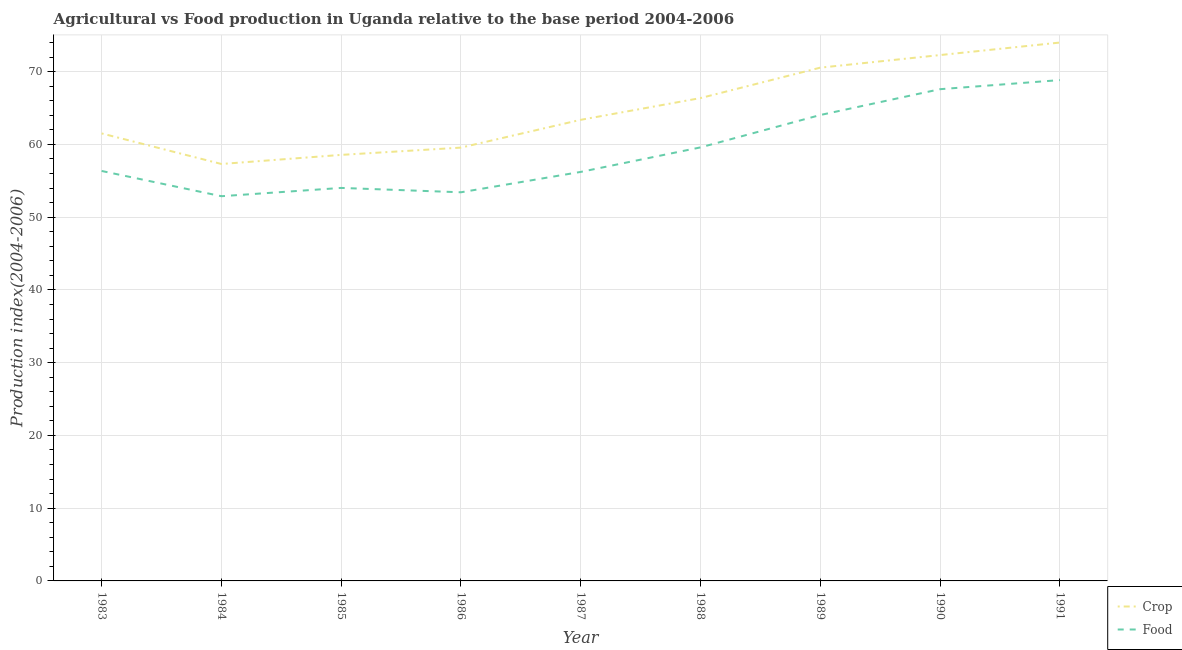What is the crop production index in 1990?
Provide a short and direct response. 72.28. Across all years, what is the minimum crop production index?
Provide a succinct answer. 57.31. In which year was the crop production index minimum?
Your response must be concise. 1984. What is the total crop production index in the graph?
Your answer should be very brief. 583.52. What is the difference between the crop production index in 1983 and that in 1990?
Your answer should be compact. -10.77. What is the difference between the food production index in 1989 and the crop production index in 1990?
Offer a very short reply. -8.24. What is the average food production index per year?
Provide a succinct answer. 59.22. In the year 1989, what is the difference between the food production index and crop production index?
Keep it short and to the point. -6.51. What is the ratio of the crop production index in 1983 to that in 1991?
Your answer should be very brief. 0.83. Is the food production index in 1984 less than that in 1985?
Your response must be concise. Yes. What is the difference between the highest and the second highest crop production index?
Offer a terse response. 1.72. What is the difference between the highest and the lowest food production index?
Ensure brevity in your answer.  15.96. Does the crop production index monotonically increase over the years?
Give a very brief answer. No. Is the crop production index strictly greater than the food production index over the years?
Offer a terse response. Yes. Is the food production index strictly less than the crop production index over the years?
Ensure brevity in your answer.  Yes. How many years are there in the graph?
Your response must be concise. 9. Does the graph contain any zero values?
Offer a terse response. No. How many legend labels are there?
Provide a succinct answer. 2. What is the title of the graph?
Keep it short and to the point. Agricultural vs Food production in Uganda relative to the base period 2004-2006. What is the label or title of the X-axis?
Offer a terse response. Year. What is the label or title of the Y-axis?
Offer a very short reply. Production index(2004-2006). What is the Production index(2004-2006) in Crop in 1983?
Provide a short and direct response. 61.51. What is the Production index(2004-2006) in Food in 1983?
Keep it short and to the point. 56.35. What is the Production index(2004-2006) of Crop in 1984?
Make the answer very short. 57.31. What is the Production index(2004-2006) of Food in 1984?
Keep it short and to the point. 52.88. What is the Production index(2004-2006) in Crop in 1985?
Your answer should be very brief. 58.56. What is the Production index(2004-2006) of Food in 1985?
Provide a succinct answer. 54.02. What is the Production index(2004-2006) of Crop in 1986?
Keep it short and to the point. 59.56. What is the Production index(2004-2006) of Food in 1986?
Provide a succinct answer. 53.42. What is the Production index(2004-2006) of Crop in 1987?
Offer a terse response. 63.38. What is the Production index(2004-2006) of Food in 1987?
Keep it short and to the point. 56.22. What is the Production index(2004-2006) of Crop in 1988?
Give a very brief answer. 66.37. What is the Production index(2004-2006) in Food in 1988?
Your response must be concise. 59.59. What is the Production index(2004-2006) in Crop in 1989?
Give a very brief answer. 70.55. What is the Production index(2004-2006) of Food in 1989?
Keep it short and to the point. 64.04. What is the Production index(2004-2006) of Crop in 1990?
Offer a very short reply. 72.28. What is the Production index(2004-2006) of Food in 1990?
Provide a short and direct response. 67.59. What is the Production index(2004-2006) in Food in 1991?
Your answer should be very brief. 68.84. Across all years, what is the maximum Production index(2004-2006) of Food?
Provide a short and direct response. 68.84. Across all years, what is the minimum Production index(2004-2006) of Crop?
Your answer should be very brief. 57.31. Across all years, what is the minimum Production index(2004-2006) in Food?
Give a very brief answer. 52.88. What is the total Production index(2004-2006) in Crop in the graph?
Offer a very short reply. 583.52. What is the total Production index(2004-2006) in Food in the graph?
Your response must be concise. 532.95. What is the difference between the Production index(2004-2006) of Crop in 1983 and that in 1984?
Offer a terse response. 4.2. What is the difference between the Production index(2004-2006) in Food in 1983 and that in 1984?
Ensure brevity in your answer.  3.47. What is the difference between the Production index(2004-2006) in Crop in 1983 and that in 1985?
Provide a short and direct response. 2.95. What is the difference between the Production index(2004-2006) of Food in 1983 and that in 1985?
Your response must be concise. 2.33. What is the difference between the Production index(2004-2006) of Crop in 1983 and that in 1986?
Keep it short and to the point. 1.95. What is the difference between the Production index(2004-2006) in Food in 1983 and that in 1986?
Offer a terse response. 2.93. What is the difference between the Production index(2004-2006) in Crop in 1983 and that in 1987?
Keep it short and to the point. -1.87. What is the difference between the Production index(2004-2006) in Food in 1983 and that in 1987?
Provide a succinct answer. 0.13. What is the difference between the Production index(2004-2006) of Crop in 1983 and that in 1988?
Offer a terse response. -4.86. What is the difference between the Production index(2004-2006) of Food in 1983 and that in 1988?
Your answer should be very brief. -3.24. What is the difference between the Production index(2004-2006) of Crop in 1983 and that in 1989?
Provide a succinct answer. -9.04. What is the difference between the Production index(2004-2006) of Food in 1983 and that in 1989?
Make the answer very short. -7.69. What is the difference between the Production index(2004-2006) in Crop in 1983 and that in 1990?
Offer a very short reply. -10.77. What is the difference between the Production index(2004-2006) in Food in 1983 and that in 1990?
Your answer should be compact. -11.24. What is the difference between the Production index(2004-2006) of Crop in 1983 and that in 1991?
Give a very brief answer. -12.49. What is the difference between the Production index(2004-2006) of Food in 1983 and that in 1991?
Your answer should be very brief. -12.49. What is the difference between the Production index(2004-2006) of Crop in 1984 and that in 1985?
Offer a very short reply. -1.25. What is the difference between the Production index(2004-2006) in Food in 1984 and that in 1985?
Your response must be concise. -1.14. What is the difference between the Production index(2004-2006) in Crop in 1984 and that in 1986?
Ensure brevity in your answer.  -2.25. What is the difference between the Production index(2004-2006) in Food in 1984 and that in 1986?
Offer a very short reply. -0.54. What is the difference between the Production index(2004-2006) of Crop in 1984 and that in 1987?
Make the answer very short. -6.07. What is the difference between the Production index(2004-2006) of Food in 1984 and that in 1987?
Ensure brevity in your answer.  -3.34. What is the difference between the Production index(2004-2006) of Crop in 1984 and that in 1988?
Give a very brief answer. -9.06. What is the difference between the Production index(2004-2006) of Food in 1984 and that in 1988?
Make the answer very short. -6.71. What is the difference between the Production index(2004-2006) of Crop in 1984 and that in 1989?
Keep it short and to the point. -13.24. What is the difference between the Production index(2004-2006) of Food in 1984 and that in 1989?
Offer a terse response. -11.16. What is the difference between the Production index(2004-2006) in Crop in 1984 and that in 1990?
Provide a succinct answer. -14.97. What is the difference between the Production index(2004-2006) of Food in 1984 and that in 1990?
Provide a succinct answer. -14.71. What is the difference between the Production index(2004-2006) in Crop in 1984 and that in 1991?
Your answer should be compact. -16.69. What is the difference between the Production index(2004-2006) in Food in 1984 and that in 1991?
Make the answer very short. -15.96. What is the difference between the Production index(2004-2006) in Crop in 1985 and that in 1986?
Provide a short and direct response. -1. What is the difference between the Production index(2004-2006) in Food in 1985 and that in 1986?
Your answer should be compact. 0.6. What is the difference between the Production index(2004-2006) in Crop in 1985 and that in 1987?
Offer a very short reply. -4.82. What is the difference between the Production index(2004-2006) in Food in 1985 and that in 1987?
Offer a terse response. -2.2. What is the difference between the Production index(2004-2006) of Crop in 1985 and that in 1988?
Make the answer very short. -7.81. What is the difference between the Production index(2004-2006) of Food in 1985 and that in 1988?
Provide a succinct answer. -5.57. What is the difference between the Production index(2004-2006) of Crop in 1985 and that in 1989?
Offer a very short reply. -11.99. What is the difference between the Production index(2004-2006) of Food in 1985 and that in 1989?
Keep it short and to the point. -10.02. What is the difference between the Production index(2004-2006) in Crop in 1985 and that in 1990?
Provide a short and direct response. -13.72. What is the difference between the Production index(2004-2006) in Food in 1985 and that in 1990?
Make the answer very short. -13.57. What is the difference between the Production index(2004-2006) of Crop in 1985 and that in 1991?
Your answer should be compact. -15.44. What is the difference between the Production index(2004-2006) in Food in 1985 and that in 1991?
Your answer should be very brief. -14.82. What is the difference between the Production index(2004-2006) in Crop in 1986 and that in 1987?
Your answer should be compact. -3.82. What is the difference between the Production index(2004-2006) in Food in 1986 and that in 1987?
Offer a terse response. -2.8. What is the difference between the Production index(2004-2006) of Crop in 1986 and that in 1988?
Offer a terse response. -6.81. What is the difference between the Production index(2004-2006) in Food in 1986 and that in 1988?
Your answer should be compact. -6.17. What is the difference between the Production index(2004-2006) in Crop in 1986 and that in 1989?
Make the answer very short. -10.99. What is the difference between the Production index(2004-2006) of Food in 1986 and that in 1989?
Your answer should be very brief. -10.62. What is the difference between the Production index(2004-2006) in Crop in 1986 and that in 1990?
Make the answer very short. -12.72. What is the difference between the Production index(2004-2006) of Food in 1986 and that in 1990?
Make the answer very short. -14.17. What is the difference between the Production index(2004-2006) of Crop in 1986 and that in 1991?
Your answer should be compact. -14.44. What is the difference between the Production index(2004-2006) in Food in 1986 and that in 1991?
Make the answer very short. -15.42. What is the difference between the Production index(2004-2006) of Crop in 1987 and that in 1988?
Your answer should be very brief. -2.99. What is the difference between the Production index(2004-2006) in Food in 1987 and that in 1988?
Ensure brevity in your answer.  -3.37. What is the difference between the Production index(2004-2006) in Crop in 1987 and that in 1989?
Your answer should be compact. -7.17. What is the difference between the Production index(2004-2006) of Food in 1987 and that in 1989?
Provide a short and direct response. -7.82. What is the difference between the Production index(2004-2006) of Food in 1987 and that in 1990?
Make the answer very short. -11.37. What is the difference between the Production index(2004-2006) in Crop in 1987 and that in 1991?
Keep it short and to the point. -10.62. What is the difference between the Production index(2004-2006) in Food in 1987 and that in 1991?
Offer a terse response. -12.62. What is the difference between the Production index(2004-2006) in Crop in 1988 and that in 1989?
Offer a terse response. -4.18. What is the difference between the Production index(2004-2006) of Food in 1988 and that in 1989?
Offer a terse response. -4.45. What is the difference between the Production index(2004-2006) of Crop in 1988 and that in 1990?
Your answer should be very brief. -5.91. What is the difference between the Production index(2004-2006) of Crop in 1988 and that in 1991?
Your answer should be compact. -7.63. What is the difference between the Production index(2004-2006) in Food in 1988 and that in 1991?
Provide a short and direct response. -9.25. What is the difference between the Production index(2004-2006) of Crop in 1989 and that in 1990?
Offer a very short reply. -1.73. What is the difference between the Production index(2004-2006) in Food in 1989 and that in 1990?
Offer a terse response. -3.55. What is the difference between the Production index(2004-2006) in Crop in 1989 and that in 1991?
Provide a short and direct response. -3.45. What is the difference between the Production index(2004-2006) in Crop in 1990 and that in 1991?
Offer a terse response. -1.72. What is the difference between the Production index(2004-2006) in Food in 1990 and that in 1991?
Provide a short and direct response. -1.25. What is the difference between the Production index(2004-2006) in Crop in 1983 and the Production index(2004-2006) in Food in 1984?
Offer a terse response. 8.63. What is the difference between the Production index(2004-2006) of Crop in 1983 and the Production index(2004-2006) of Food in 1985?
Your answer should be compact. 7.49. What is the difference between the Production index(2004-2006) of Crop in 1983 and the Production index(2004-2006) of Food in 1986?
Provide a short and direct response. 8.09. What is the difference between the Production index(2004-2006) in Crop in 1983 and the Production index(2004-2006) in Food in 1987?
Your answer should be very brief. 5.29. What is the difference between the Production index(2004-2006) in Crop in 1983 and the Production index(2004-2006) in Food in 1988?
Provide a short and direct response. 1.92. What is the difference between the Production index(2004-2006) in Crop in 1983 and the Production index(2004-2006) in Food in 1989?
Ensure brevity in your answer.  -2.53. What is the difference between the Production index(2004-2006) in Crop in 1983 and the Production index(2004-2006) in Food in 1990?
Offer a terse response. -6.08. What is the difference between the Production index(2004-2006) of Crop in 1983 and the Production index(2004-2006) of Food in 1991?
Your answer should be very brief. -7.33. What is the difference between the Production index(2004-2006) in Crop in 1984 and the Production index(2004-2006) in Food in 1985?
Your response must be concise. 3.29. What is the difference between the Production index(2004-2006) in Crop in 1984 and the Production index(2004-2006) in Food in 1986?
Your answer should be very brief. 3.89. What is the difference between the Production index(2004-2006) of Crop in 1984 and the Production index(2004-2006) of Food in 1987?
Provide a short and direct response. 1.09. What is the difference between the Production index(2004-2006) in Crop in 1984 and the Production index(2004-2006) in Food in 1988?
Give a very brief answer. -2.28. What is the difference between the Production index(2004-2006) in Crop in 1984 and the Production index(2004-2006) in Food in 1989?
Offer a very short reply. -6.73. What is the difference between the Production index(2004-2006) of Crop in 1984 and the Production index(2004-2006) of Food in 1990?
Provide a succinct answer. -10.28. What is the difference between the Production index(2004-2006) of Crop in 1984 and the Production index(2004-2006) of Food in 1991?
Ensure brevity in your answer.  -11.53. What is the difference between the Production index(2004-2006) in Crop in 1985 and the Production index(2004-2006) in Food in 1986?
Your answer should be compact. 5.14. What is the difference between the Production index(2004-2006) of Crop in 1985 and the Production index(2004-2006) of Food in 1987?
Keep it short and to the point. 2.34. What is the difference between the Production index(2004-2006) of Crop in 1985 and the Production index(2004-2006) of Food in 1988?
Give a very brief answer. -1.03. What is the difference between the Production index(2004-2006) in Crop in 1985 and the Production index(2004-2006) in Food in 1989?
Ensure brevity in your answer.  -5.48. What is the difference between the Production index(2004-2006) of Crop in 1985 and the Production index(2004-2006) of Food in 1990?
Your answer should be compact. -9.03. What is the difference between the Production index(2004-2006) of Crop in 1985 and the Production index(2004-2006) of Food in 1991?
Provide a short and direct response. -10.28. What is the difference between the Production index(2004-2006) in Crop in 1986 and the Production index(2004-2006) in Food in 1987?
Provide a succinct answer. 3.34. What is the difference between the Production index(2004-2006) of Crop in 1986 and the Production index(2004-2006) of Food in 1988?
Provide a short and direct response. -0.03. What is the difference between the Production index(2004-2006) in Crop in 1986 and the Production index(2004-2006) in Food in 1989?
Give a very brief answer. -4.48. What is the difference between the Production index(2004-2006) in Crop in 1986 and the Production index(2004-2006) in Food in 1990?
Provide a short and direct response. -8.03. What is the difference between the Production index(2004-2006) of Crop in 1986 and the Production index(2004-2006) of Food in 1991?
Make the answer very short. -9.28. What is the difference between the Production index(2004-2006) of Crop in 1987 and the Production index(2004-2006) of Food in 1988?
Provide a short and direct response. 3.79. What is the difference between the Production index(2004-2006) in Crop in 1987 and the Production index(2004-2006) in Food in 1989?
Your answer should be very brief. -0.66. What is the difference between the Production index(2004-2006) of Crop in 1987 and the Production index(2004-2006) of Food in 1990?
Provide a short and direct response. -4.21. What is the difference between the Production index(2004-2006) of Crop in 1987 and the Production index(2004-2006) of Food in 1991?
Offer a terse response. -5.46. What is the difference between the Production index(2004-2006) in Crop in 1988 and the Production index(2004-2006) in Food in 1989?
Keep it short and to the point. 2.33. What is the difference between the Production index(2004-2006) in Crop in 1988 and the Production index(2004-2006) in Food in 1990?
Offer a terse response. -1.22. What is the difference between the Production index(2004-2006) in Crop in 1988 and the Production index(2004-2006) in Food in 1991?
Provide a short and direct response. -2.47. What is the difference between the Production index(2004-2006) of Crop in 1989 and the Production index(2004-2006) of Food in 1990?
Give a very brief answer. 2.96. What is the difference between the Production index(2004-2006) in Crop in 1989 and the Production index(2004-2006) in Food in 1991?
Offer a very short reply. 1.71. What is the difference between the Production index(2004-2006) in Crop in 1990 and the Production index(2004-2006) in Food in 1991?
Provide a short and direct response. 3.44. What is the average Production index(2004-2006) of Crop per year?
Offer a terse response. 64.84. What is the average Production index(2004-2006) of Food per year?
Make the answer very short. 59.22. In the year 1983, what is the difference between the Production index(2004-2006) in Crop and Production index(2004-2006) in Food?
Provide a short and direct response. 5.16. In the year 1984, what is the difference between the Production index(2004-2006) of Crop and Production index(2004-2006) of Food?
Ensure brevity in your answer.  4.43. In the year 1985, what is the difference between the Production index(2004-2006) of Crop and Production index(2004-2006) of Food?
Make the answer very short. 4.54. In the year 1986, what is the difference between the Production index(2004-2006) in Crop and Production index(2004-2006) in Food?
Give a very brief answer. 6.14. In the year 1987, what is the difference between the Production index(2004-2006) of Crop and Production index(2004-2006) of Food?
Offer a very short reply. 7.16. In the year 1988, what is the difference between the Production index(2004-2006) in Crop and Production index(2004-2006) in Food?
Offer a terse response. 6.78. In the year 1989, what is the difference between the Production index(2004-2006) in Crop and Production index(2004-2006) in Food?
Your answer should be compact. 6.51. In the year 1990, what is the difference between the Production index(2004-2006) of Crop and Production index(2004-2006) of Food?
Give a very brief answer. 4.69. In the year 1991, what is the difference between the Production index(2004-2006) in Crop and Production index(2004-2006) in Food?
Your answer should be very brief. 5.16. What is the ratio of the Production index(2004-2006) in Crop in 1983 to that in 1984?
Provide a succinct answer. 1.07. What is the ratio of the Production index(2004-2006) of Food in 1983 to that in 1984?
Offer a terse response. 1.07. What is the ratio of the Production index(2004-2006) of Crop in 1983 to that in 1985?
Your answer should be very brief. 1.05. What is the ratio of the Production index(2004-2006) of Food in 1983 to that in 1985?
Your answer should be very brief. 1.04. What is the ratio of the Production index(2004-2006) of Crop in 1983 to that in 1986?
Provide a succinct answer. 1.03. What is the ratio of the Production index(2004-2006) of Food in 1983 to that in 1986?
Offer a terse response. 1.05. What is the ratio of the Production index(2004-2006) of Crop in 1983 to that in 1987?
Offer a terse response. 0.97. What is the ratio of the Production index(2004-2006) of Food in 1983 to that in 1987?
Your answer should be compact. 1. What is the ratio of the Production index(2004-2006) of Crop in 1983 to that in 1988?
Your answer should be compact. 0.93. What is the ratio of the Production index(2004-2006) of Food in 1983 to that in 1988?
Your response must be concise. 0.95. What is the ratio of the Production index(2004-2006) of Crop in 1983 to that in 1989?
Give a very brief answer. 0.87. What is the ratio of the Production index(2004-2006) of Food in 1983 to that in 1989?
Ensure brevity in your answer.  0.88. What is the ratio of the Production index(2004-2006) of Crop in 1983 to that in 1990?
Offer a very short reply. 0.85. What is the ratio of the Production index(2004-2006) of Food in 1983 to that in 1990?
Ensure brevity in your answer.  0.83. What is the ratio of the Production index(2004-2006) of Crop in 1983 to that in 1991?
Your answer should be very brief. 0.83. What is the ratio of the Production index(2004-2006) of Food in 1983 to that in 1991?
Your response must be concise. 0.82. What is the ratio of the Production index(2004-2006) of Crop in 1984 to that in 1985?
Offer a terse response. 0.98. What is the ratio of the Production index(2004-2006) in Food in 1984 to that in 1985?
Your answer should be compact. 0.98. What is the ratio of the Production index(2004-2006) in Crop in 1984 to that in 1986?
Keep it short and to the point. 0.96. What is the ratio of the Production index(2004-2006) of Crop in 1984 to that in 1987?
Provide a succinct answer. 0.9. What is the ratio of the Production index(2004-2006) in Food in 1984 to that in 1987?
Your answer should be very brief. 0.94. What is the ratio of the Production index(2004-2006) in Crop in 1984 to that in 1988?
Make the answer very short. 0.86. What is the ratio of the Production index(2004-2006) in Food in 1984 to that in 1988?
Provide a short and direct response. 0.89. What is the ratio of the Production index(2004-2006) of Crop in 1984 to that in 1989?
Your answer should be very brief. 0.81. What is the ratio of the Production index(2004-2006) in Food in 1984 to that in 1989?
Offer a terse response. 0.83. What is the ratio of the Production index(2004-2006) in Crop in 1984 to that in 1990?
Keep it short and to the point. 0.79. What is the ratio of the Production index(2004-2006) of Food in 1984 to that in 1990?
Keep it short and to the point. 0.78. What is the ratio of the Production index(2004-2006) in Crop in 1984 to that in 1991?
Your answer should be compact. 0.77. What is the ratio of the Production index(2004-2006) in Food in 1984 to that in 1991?
Your answer should be very brief. 0.77. What is the ratio of the Production index(2004-2006) in Crop in 1985 to that in 1986?
Provide a short and direct response. 0.98. What is the ratio of the Production index(2004-2006) in Food in 1985 to that in 1986?
Provide a succinct answer. 1.01. What is the ratio of the Production index(2004-2006) of Crop in 1985 to that in 1987?
Ensure brevity in your answer.  0.92. What is the ratio of the Production index(2004-2006) in Food in 1985 to that in 1987?
Your answer should be very brief. 0.96. What is the ratio of the Production index(2004-2006) of Crop in 1985 to that in 1988?
Provide a short and direct response. 0.88. What is the ratio of the Production index(2004-2006) in Food in 1985 to that in 1988?
Your answer should be compact. 0.91. What is the ratio of the Production index(2004-2006) in Crop in 1985 to that in 1989?
Provide a succinct answer. 0.83. What is the ratio of the Production index(2004-2006) in Food in 1985 to that in 1989?
Provide a succinct answer. 0.84. What is the ratio of the Production index(2004-2006) of Crop in 1985 to that in 1990?
Make the answer very short. 0.81. What is the ratio of the Production index(2004-2006) in Food in 1985 to that in 1990?
Ensure brevity in your answer.  0.8. What is the ratio of the Production index(2004-2006) in Crop in 1985 to that in 1991?
Provide a succinct answer. 0.79. What is the ratio of the Production index(2004-2006) of Food in 1985 to that in 1991?
Provide a succinct answer. 0.78. What is the ratio of the Production index(2004-2006) of Crop in 1986 to that in 1987?
Provide a short and direct response. 0.94. What is the ratio of the Production index(2004-2006) of Food in 1986 to that in 1987?
Your response must be concise. 0.95. What is the ratio of the Production index(2004-2006) in Crop in 1986 to that in 1988?
Make the answer very short. 0.9. What is the ratio of the Production index(2004-2006) of Food in 1986 to that in 1988?
Make the answer very short. 0.9. What is the ratio of the Production index(2004-2006) in Crop in 1986 to that in 1989?
Provide a short and direct response. 0.84. What is the ratio of the Production index(2004-2006) of Food in 1986 to that in 1989?
Offer a very short reply. 0.83. What is the ratio of the Production index(2004-2006) of Crop in 1986 to that in 1990?
Offer a very short reply. 0.82. What is the ratio of the Production index(2004-2006) in Food in 1986 to that in 1990?
Provide a succinct answer. 0.79. What is the ratio of the Production index(2004-2006) of Crop in 1986 to that in 1991?
Your answer should be very brief. 0.8. What is the ratio of the Production index(2004-2006) of Food in 1986 to that in 1991?
Your answer should be very brief. 0.78. What is the ratio of the Production index(2004-2006) of Crop in 1987 to that in 1988?
Keep it short and to the point. 0.95. What is the ratio of the Production index(2004-2006) of Food in 1987 to that in 1988?
Give a very brief answer. 0.94. What is the ratio of the Production index(2004-2006) in Crop in 1987 to that in 1989?
Your response must be concise. 0.9. What is the ratio of the Production index(2004-2006) of Food in 1987 to that in 1989?
Provide a short and direct response. 0.88. What is the ratio of the Production index(2004-2006) of Crop in 1987 to that in 1990?
Your answer should be very brief. 0.88. What is the ratio of the Production index(2004-2006) of Food in 1987 to that in 1990?
Offer a very short reply. 0.83. What is the ratio of the Production index(2004-2006) of Crop in 1987 to that in 1991?
Provide a succinct answer. 0.86. What is the ratio of the Production index(2004-2006) in Food in 1987 to that in 1991?
Keep it short and to the point. 0.82. What is the ratio of the Production index(2004-2006) in Crop in 1988 to that in 1989?
Keep it short and to the point. 0.94. What is the ratio of the Production index(2004-2006) of Food in 1988 to that in 1989?
Make the answer very short. 0.93. What is the ratio of the Production index(2004-2006) in Crop in 1988 to that in 1990?
Ensure brevity in your answer.  0.92. What is the ratio of the Production index(2004-2006) in Food in 1988 to that in 1990?
Offer a terse response. 0.88. What is the ratio of the Production index(2004-2006) in Crop in 1988 to that in 1991?
Offer a terse response. 0.9. What is the ratio of the Production index(2004-2006) of Food in 1988 to that in 1991?
Give a very brief answer. 0.87. What is the ratio of the Production index(2004-2006) in Crop in 1989 to that in 1990?
Your answer should be very brief. 0.98. What is the ratio of the Production index(2004-2006) of Food in 1989 to that in 1990?
Give a very brief answer. 0.95. What is the ratio of the Production index(2004-2006) of Crop in 1989 to that in 1991?
Your answer should be very brief. 0.95. What is the ratio of the Production index(2004-2006) in Food in 1989 to that in 1991?
Provide a short and direct response. 0.93. What is the ratio of the Production index(2004-2006) of Crop in 1990 to that in 1991?
Your answer should be compact. 0.98. What is the ratio of the Production index(2004-2006) of Food in 1990 to that in 1991?
Your answer should be very brief. 0.98. What is the difference between the highest and the second highest Production index(2004-2006) of Crop?
Provide a short and direct response. 1.72. What is the difference between the highest and the second highest Production index(2004-2006) in Food?
Give a very brief answer. 1.25. What is the difference between the highest and the lowest Production index(2004-2006) in Crop?
Provide a short and direct response. 16.69. What is the difference between the highest and the lowest Production index(2004-2006) in Food?
Offer a terse response. 15.96. 